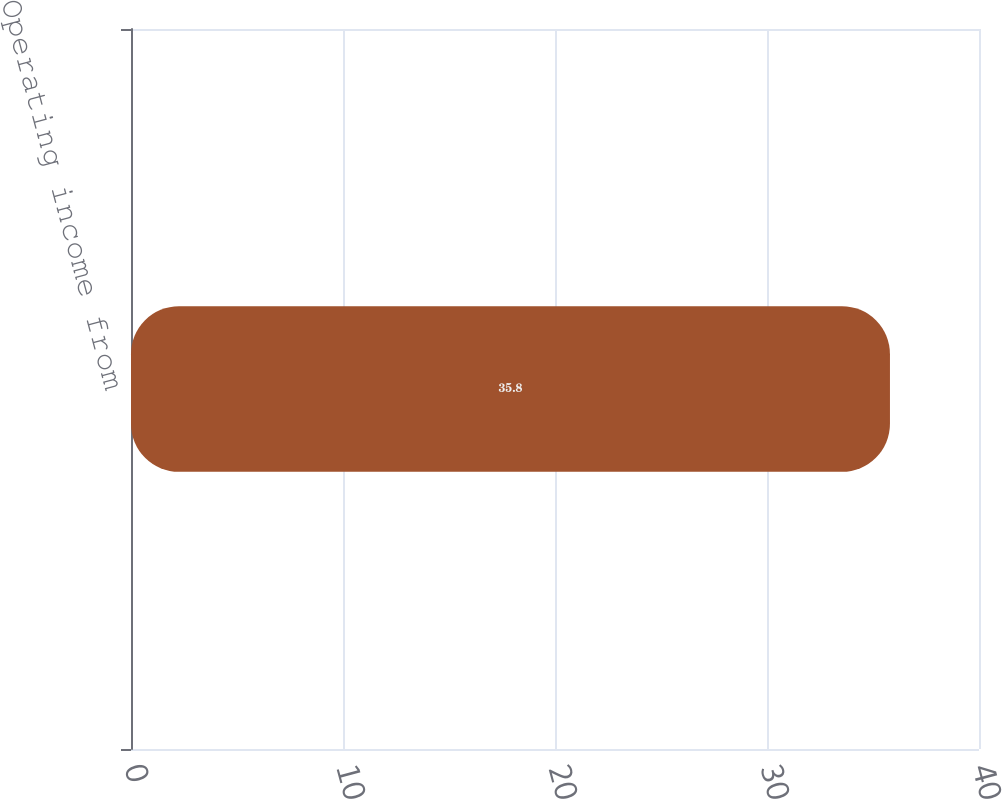Convert chart to OTSL. <chart><loc_0><loc_0><loc_500><loc_500><bar_chart><fcel>Operating income from<nl><fcel>35.8<nl></chart> 